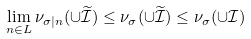Convert formula to latex. <formula><loc_0><loc_0><loc_500><loc_500>\lim _ { n \in L } \nu _ { \sigma | n } ( \cup \widetilde { \mathcal { I } } ) \leq \nu _ { \sigma } ( \cup \widetilde { \mathcal { I } } ) \leq \nu _ { \sigma } ( \cup \mathcal { I } )</formula> 